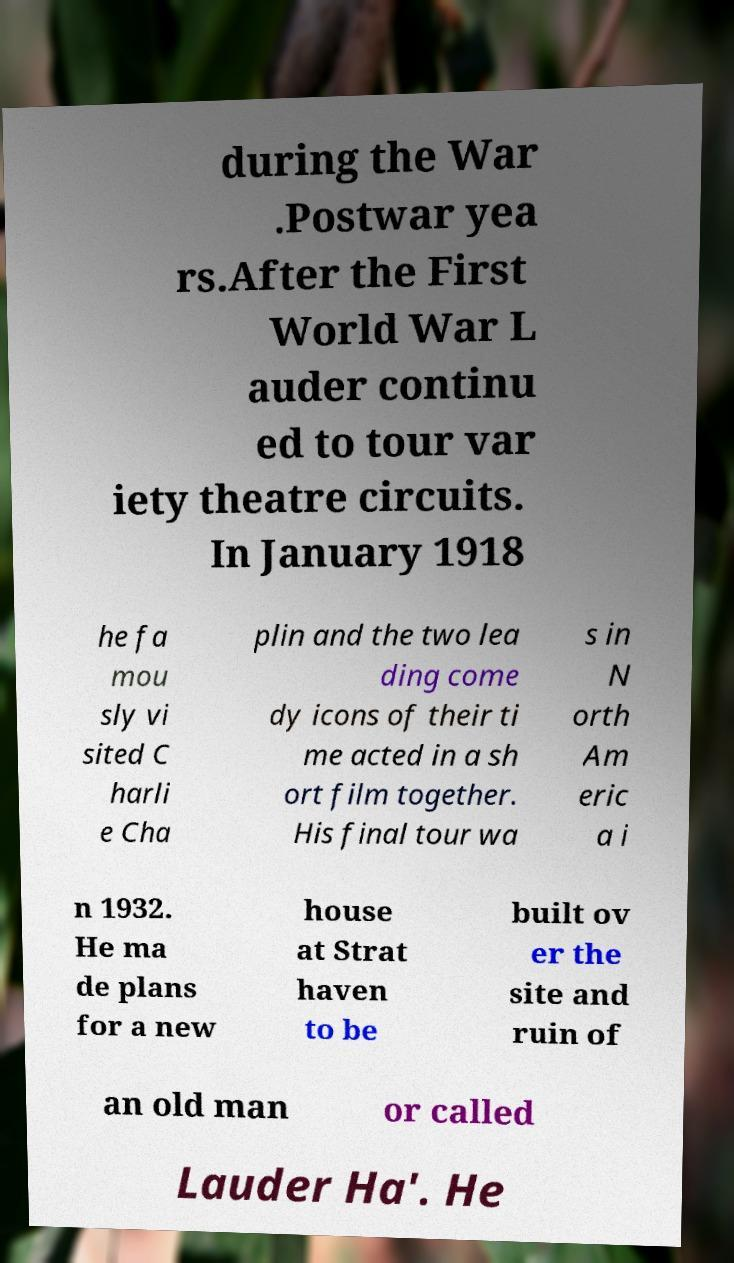Can you accurately transcribe the text from the provided image for me? during the War .Postwar yea rs.After the First World War L auder continu ed to tour var iety theatre circuits. In January 1918 he fa mou sly vi sited C harli e Cha plin and the two lea ding come dy icons of their ti me acted in a sh ort film together. His final tour wa s in N orth Am eric a i n 1932. He ma de plans for a new house at Strat haven to be built ov er the site and ruin of an old man or called Lauder Ha'. He 